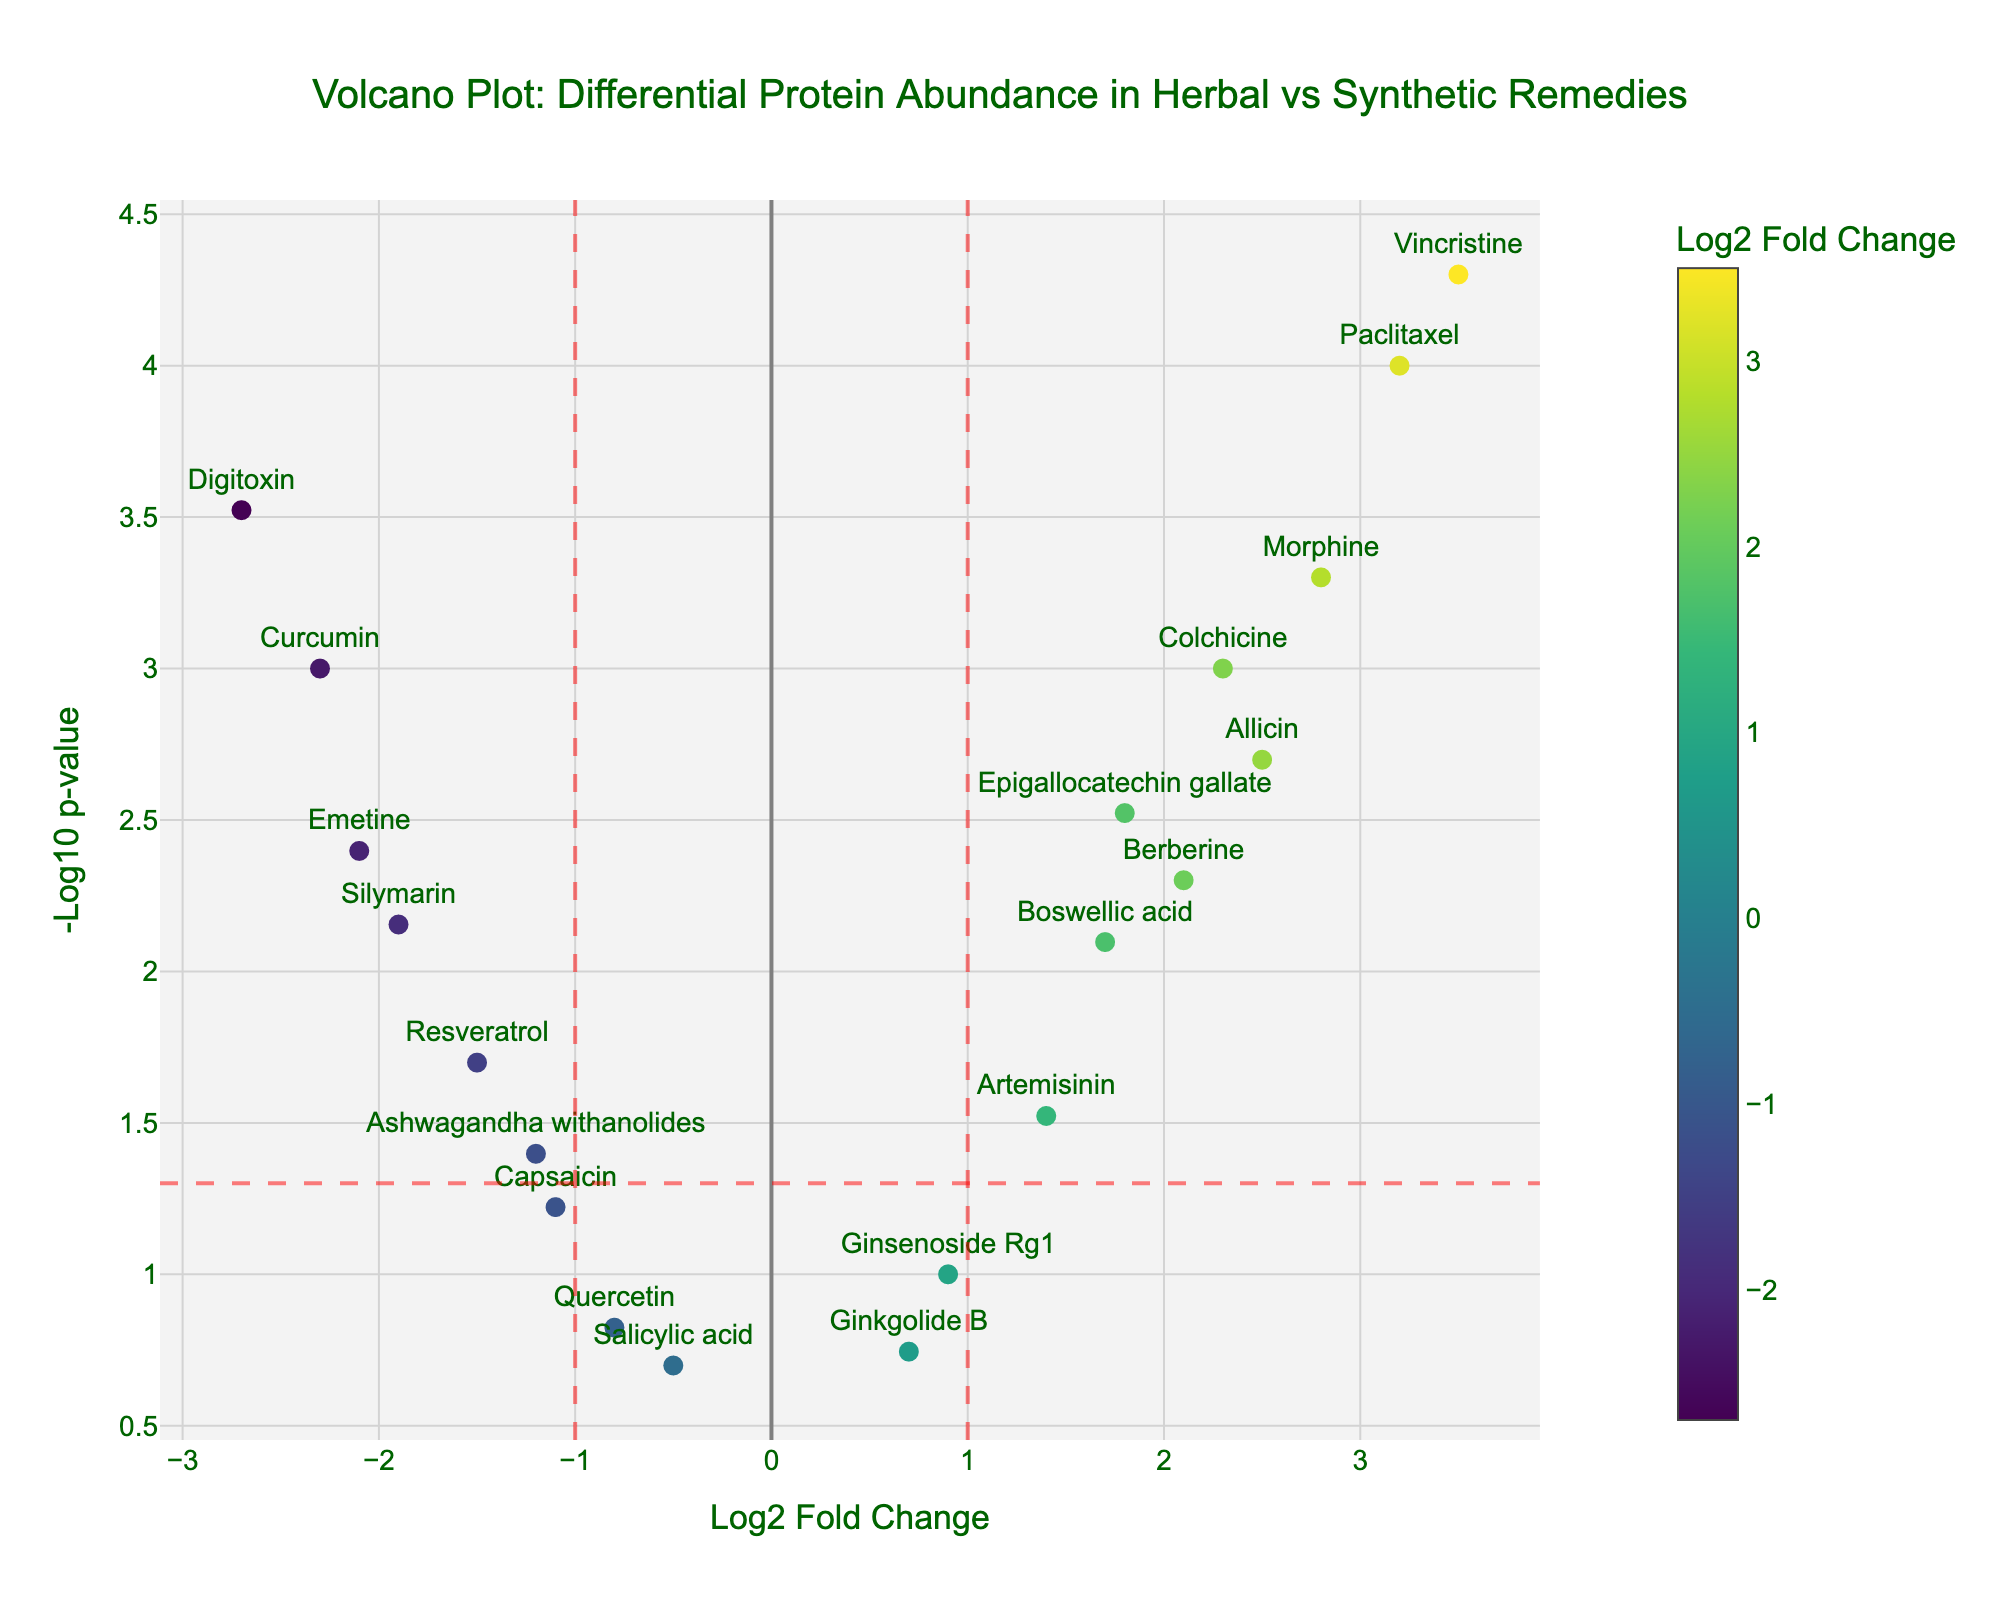How many proteins in total are shown in the plot? Count the number of unique data points on the plot. Each point represents a protein.
Answer: 20 What is the title of the plot? Observe the title text at the top of the plot.
Answer: Volcano Plot: Differential Protein Abundance in Herbal vs Synthetic Remedies Which protein has the highest log2 fold change? Identify the data point farthest to the right on the x-axis, and look at the corresponding protein name.
Answer: Vincristine What are the units used on the x-axis? Look at the label on the x-axis of the plot.
Answer: Log2 Fold Change Are there any proteins with a p-value above 0.05? Check if any point has a -log10(p-value) less than -log10(0.05), which appears below the horizontal red dashed line.
Answer: Yes Which proteins fall within the threshold of significant fold change (log2 fold change >= 1 or <= -1) and significant p-value (p < 0.05)? Identify proteins that are either right of x=1 or left of x=-1 and above the horizontal red dashed line.
Answer: Curcumin, Epigallocatechin gallate, Resveratrol, Berberine, Ashwagandha withanolides, Boswellic acid, Allicin, Silymarin, Paclitaxel, Artemisinin, Morphine, Digitoxin, Vincristine, Colchicine, Emetine Which synthetic drug has the highest p-value among the significant proteins? Identify synthetic drugs within the thresholds and find the one with the lowest -log10(p-value).
Answer: Artemisinin What is the total number of herbal proteins that are significantly differentially expressed in comparison to synthetic drugs? Count the herbal proteins that fall within the significant fold change and p-value thresholds.
Answer: 11 Which significantly expressed protein has the smallest log2 fold change? Identify the point within the significance thresholds that is closest to zero along the x-axis.
Answer: Epigallocatechin gallate Between Morphine and Colchicine, which has a greater differential protein abundance? Compare their log2 fold change values on the x-axis.
Answer: Colchicine 